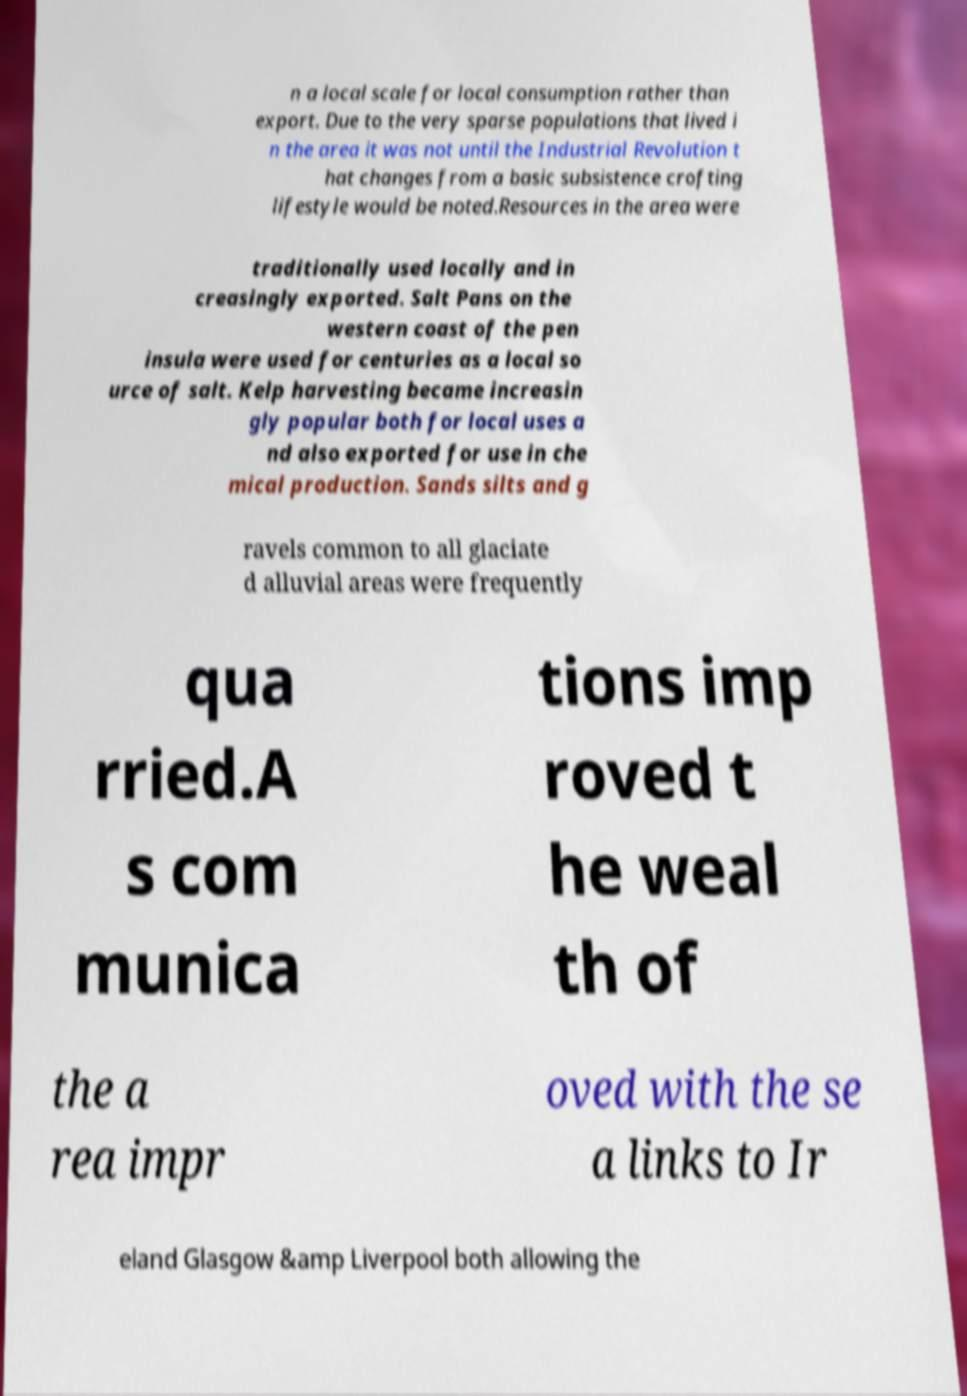What messages or text are displayed in this image? I need them in a readable, typed format. n a local scale for local consumption rather than export. Due to the very sparse populations that lived i n the area it was not until the Industrial Revolution t hat changes from a basic subsistence crofting lifestyle would be noted.Resources in the area were traditionally used locally and in creasingly exported. Salt Pans on the western coast of the pen insula were used for centuries as a local so urce of salt. Kelp harvesting became increasin gly popular both for local uses a nd also exported for use in che mical production. Sands silts and g ravels common to all glaciate d alluvial areas were frequently qua rried.A s com munica tions imp roved t he weal th of the a rea impr oved with the se a links to Ir eland Glasgow &amp Liverpool both allowing the 